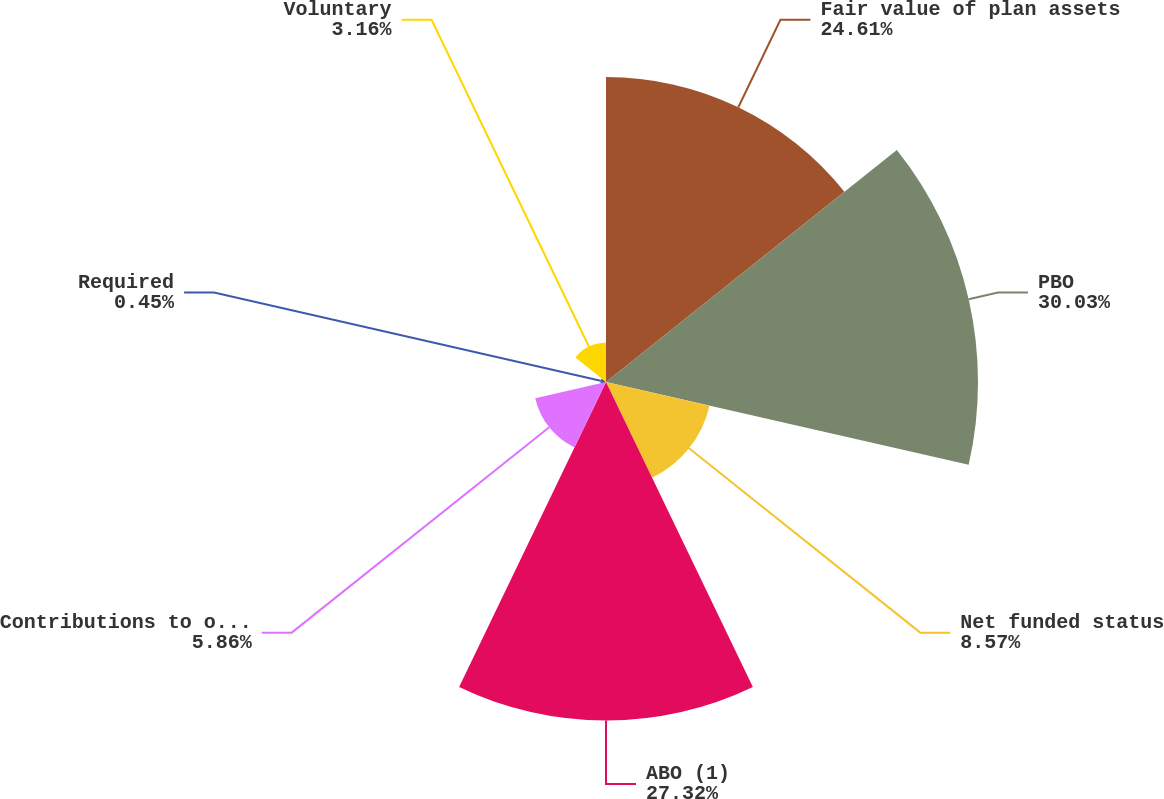<chart> <loc_0><loc_0><loc_500><loc_500><pie_chart><fcel>Fair value of plan assets<fcel>PBO<fcel>Net funded status<fcel>ABO (1)<fcel>Contributions to our US<fcel>Required<fcel>Voluntary<nl><fcel>24.61%<fcel>30.02%<fcel>8.57%<fcel>27.32%<fcel>5.86%<fcel>0.45%<fcel>3.16%<nl></chart> 